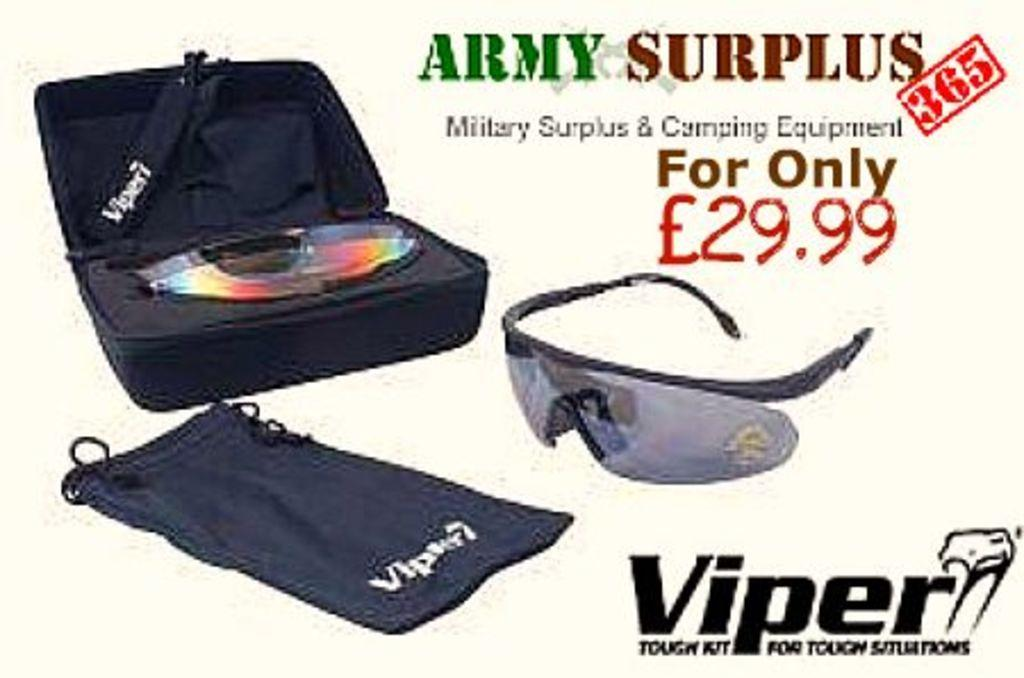What object can be seen in the image that is commonly used for carrying belongings? There is a suitcase in the image that is commonly used for carrying belongings. What type of material is present in the image that can be used for covering or cleaning? There is a cloth in the image that can be used for covering or cleaning. What type of eyewear is present in the image with text written on it? There are goggles with text written on them in the image. What type of wall can be seen in the image with bikes hanging on it? There is no wall or bikes present in the image; it only features a suitcase, cloth, and goggles. 